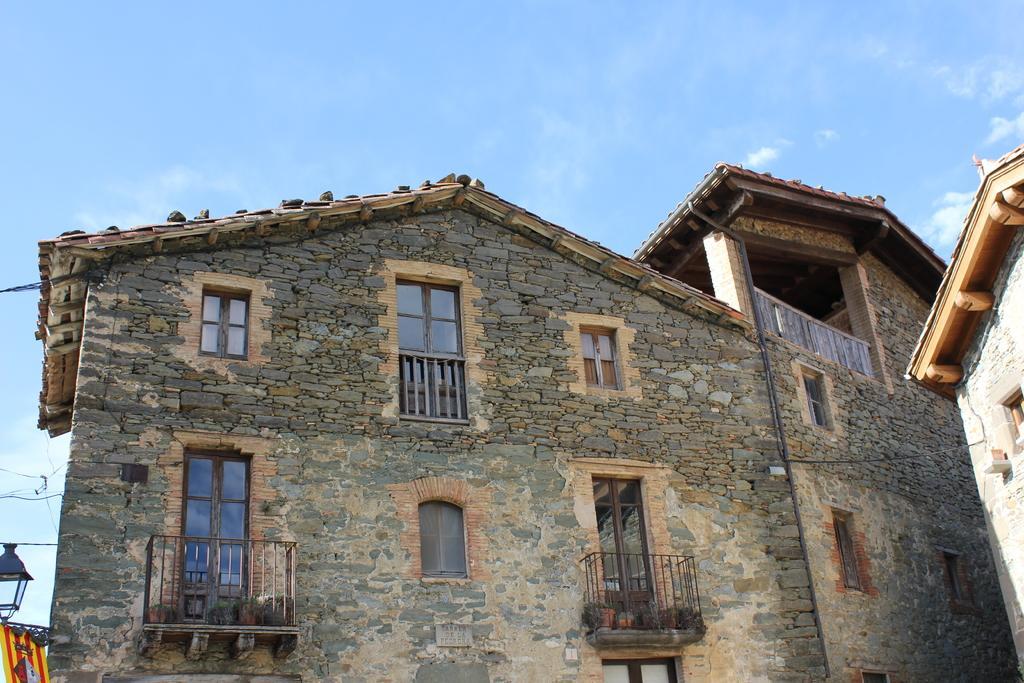Can you describe this image briefly? In this image in the center there is a building, and on the left side there is a railing. At the top there is sky. 